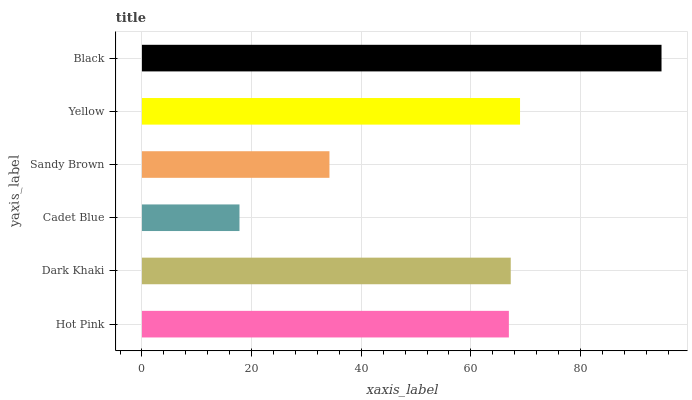Is Cadet Blue the minimum?
Answer yes or no. Yes. Is Black the maximum?
Answer yes or no. Yes. Is Dark Khaki the minimum?
Answer yes or no. No. Is Dark Khaki the maximum?
Answer yes or no. No. Is Dark Khaki greater than Hot Pink?
Answer yes or no. Yes. Is Hot Pink less than Dark Khaki?
Answer yes or no. Yes. Is Hot Pink greater than Dark Khaki?
Answer yes or no. No. Is Dark Khaki less than Hot Pink?
Answer yes or no. No. Is Dark Khaki the high median?
Answer yes or no. Yes. Is Hot Pink the low median?
Answer yes or no. Yes. Is Hot Pink the high median?
Answer yes or no. No. Is Black the low median?
Answer yes or no. No. 